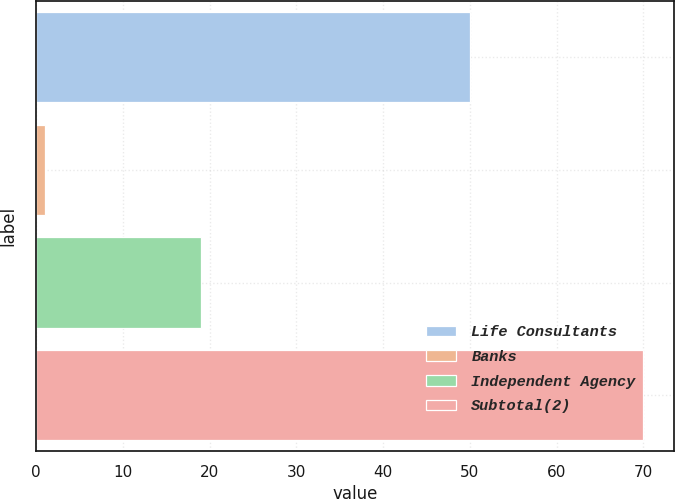Convert chart. <chart><loc_0><loc_0><loc_500><loc_500><bar_chart><fcel>Life Consultants<fcel>Banks<fcel>Independent Agency<fcel>Subtotal(2)<nl><fcel>50<fcel>1<fcel>19<fcel>70<nl></chart> 